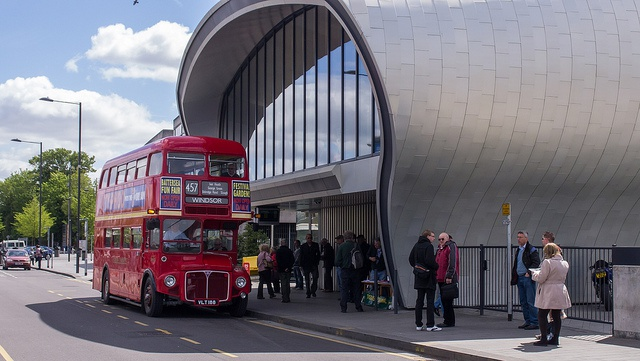Describe the objects in this image and their specific colors. I can see bus in lightblue, black, maroon, gray, and brown tones, people in lightblue, black, and gray tones, people in lightblue, black, gray, and maroon tones, people in lightblue, black, gray, maroon, and purple tones, and people in lightblue, black, navy, gray, and darkblue tones in this image. 